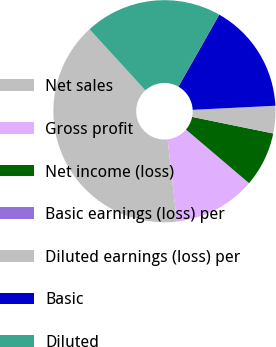Convert chart. <chart><loc_0><loc_0><loc_500><loc_500><pie_chart><fcel>Net sales<fcel>Gross profit<fcel>Net income (loss)<fcel>Basic earnings (loss) per<fcel>Diluted earnings (loss) per<fcel>Basic<fcel>Diluted<nl><fcel>40.0%<fcel>12.0%<fcel>8.0%<fcel>0.0%<fcel>4.0%<fcel>16.0%<fcel>20.0%<nl></chart> 